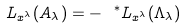Convert formula to latex. <formula><loc_0><loc_0><loc_500><loc_500>L _ { x ^ { \lambda } } ( A _ { \lambda } ) = - \ ^ { * } L _ { x ^ { \lambda } } ( \Lambda _ { \lambda } )</formula> 